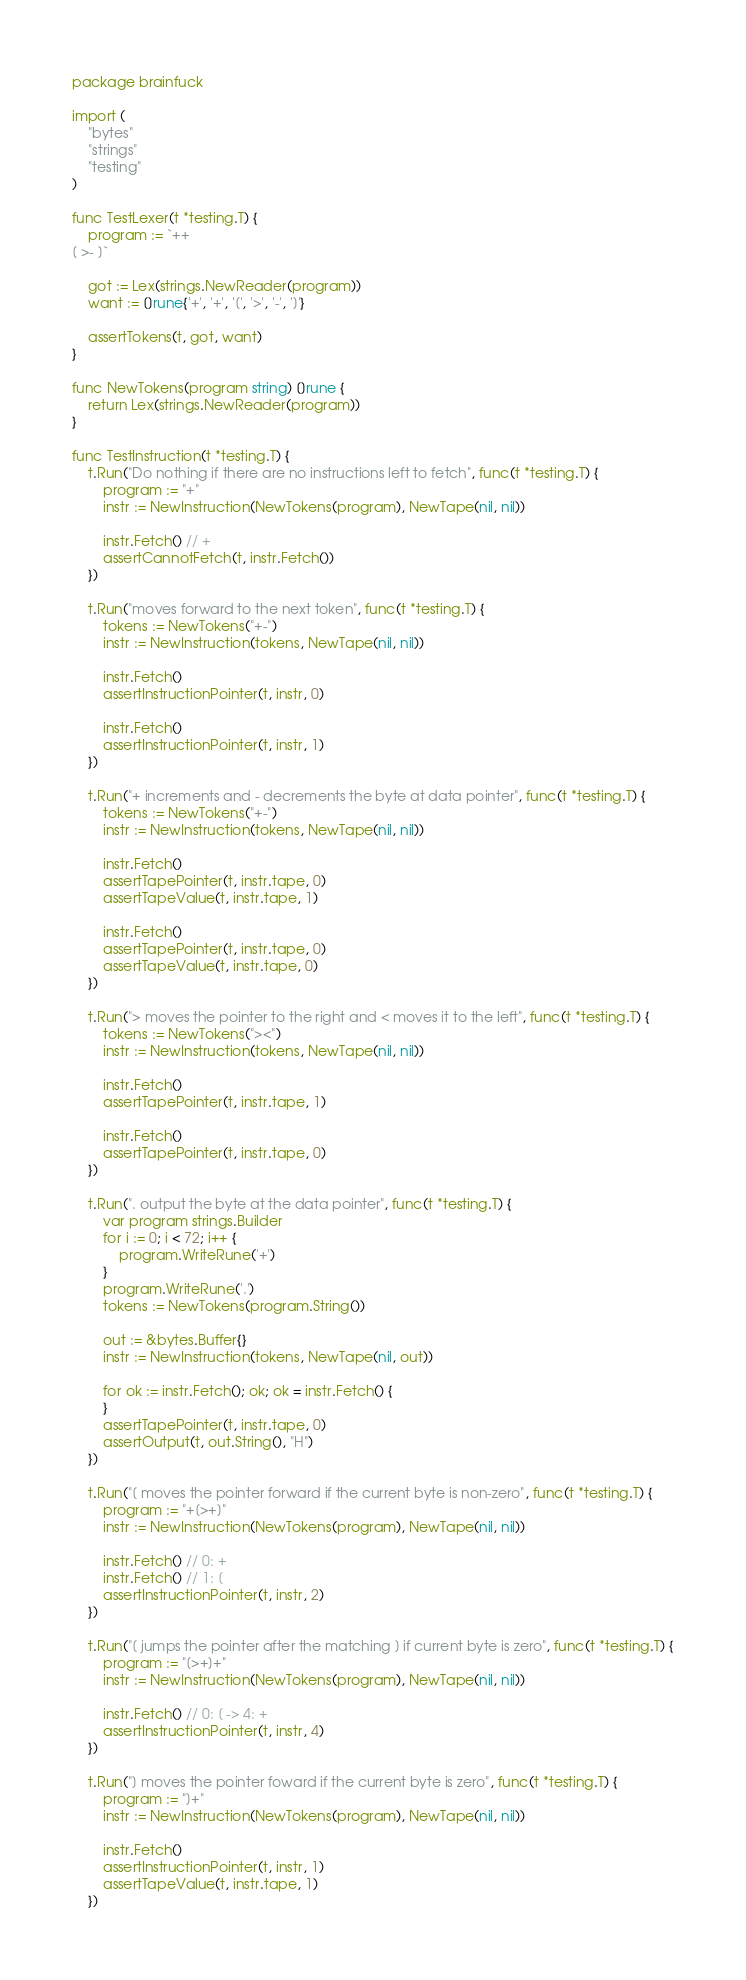<code> <loc_0><loc_0><loc_500><loc_500><_Go_>package brainfuck

import (
	"bytes"
	"strings"
	"testing"
)

func TestLexer(t *testing.T) {
	program := `++
[ >- ]`

	got := Lex(strings.NewReader(program))
	want := []rune{'+', '+', '[', '>', '-', ']'}

	assertTokens(t, got, want)
}

func NewTokens(program string) []rune {
	return Lex(strings.NewReader(program))
}

func TestInstruction(t *testing.T) {
	t.Run("Do nothing if there are no instructions left to fetch", func(t *testing.T) {
		program := "+"
		instr := NewInstruction(NewTokens(program), NewTape(nil, nil))

		instr.Fetch() // +
		assertCannotFetch(t, instr.Fetch())
	})

	t.Run("moves forward to the next token", func(t *testing.T) {
		tokens := NewTokens("+-")
		instr := NewInstruction(tokens, NewTape(nil, nil))

		instr.Fetch()
		assertInstructionPointer(t, instr, 0)

		instr.Fetch()
		assertInstructionPointer(t, instr, 1)
	})

	t.Run("+ increments and - decrements the byte at data pointer", func(t *testing.T) {
		tokens := NewTokens("+-")
		instr := NewInstruction(tokens, NewTape(nil, nil))

		instr.Fetch()
		assertTapePointer(t, instr.tape, 0)
		assertTapeValue(t, instr.tape, 1)

		instr.Fetch()
		assertTapePointer(t, instr.tape, 0)
		assertTapeValue(t, instr.tape, 0)
	})

	t.Run("> moves the pointer to the right and < moves it to the left", func(t *testing.T) {
		tokens := NewTokens("><")
		instr := NewInstruction(tokens, NewTape(nil, nil))

		instr.Fetch()
		assertTapePointer(t, instr.tape, 1)

		instr.Fetch()
		assertTapePointer(t, instr.tape, 0)
	})

	t.Run(". output the byte at the data pointer", func(t *testing.T) {
		var program strings.Builder
		for i := 0; i < 72; i++ {
			program.WriteRune('+')
		}
		program.WriteRune('.')
		tokens := NewTokens(program.String())

		out := &bytes.Buffer{}
		instr := NewInstruction(tokens, NewTape(nil, out))

		for ok := instr.Fetch(); ok; ok = instr.Fetch() {
		}
		assertTapePointer(t, instr.tape, 0)
		assertOutput(t, out.String(), "H")
	})

	t.Run("[ moves the pointer forward if the current byte is non-zero", func(t *testing.T) {
		program := "+[>+]"
		instr := NewInstruction(NewTokens(program), NewTape(nil, nil))

		instr.Fetch() // 0: +
		instr.Fetch() // 1: [
		assertInstructionPointer(t, instr, 2)
	})

	t.Run("[ jumps the pointer after the matching ] if current byte is zero", func(t *testing.T) {
		program := "[>+]+"
		instr := NewInstruction(NewTokens(program), NewTape(nil, nil))

		instr.Fetch() // 0: [ -> 4: +
		assertInstructionPointer(t, instr, 4)
	})

	t.Run("] moves the pointer foward if the current byte is zero", func(t *testing.T) {
		program := "]+"
		instr := NewInstruction(NewTokens(program), NewTape(nil, nil))

		instr.Fetch()
		assertInstructionPointer(t, instr, 1)
		assertTapeValue(t, instr.tape, 1)
	})
</code> 